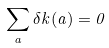<formula> <loc_0><loc_0><loc_500><loc_500>\sum _ { a } \delta k ( a ) = 0</formula> 